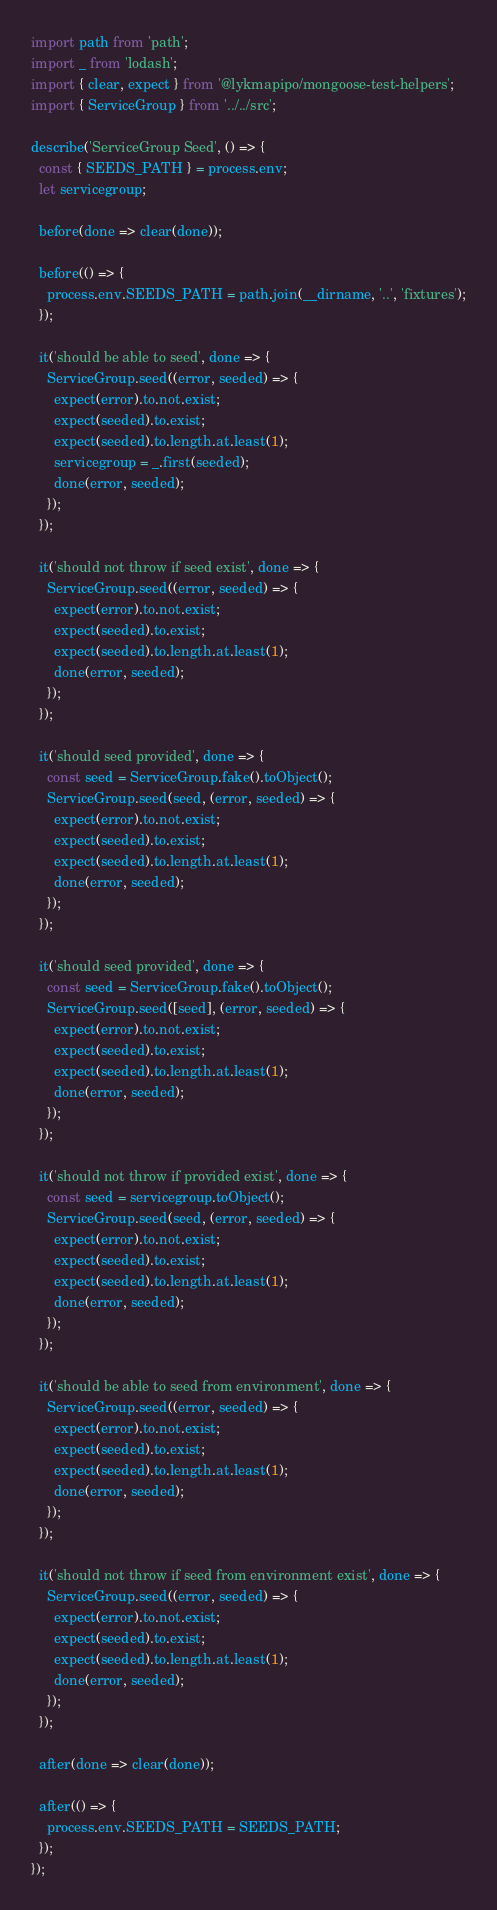Convert code to text. <code><loc_0><loc_0><loc_500><loc_500><_JavaScript_>import path from 'path';
import _ from 'lodash';
import { clear, expect } from '@lykmapipo/mongoose-test-helpers';
import { ServiceGroup } from '../../src';

describe('ServiceGroup Seed', () => {
  const { SEEDS_PATH } = process.env;
  let servicegroup;

  before(done => clear(done));

  before(() => {
    process.env.SEEDS_PATH = path.join(__dirname, '..', 'fixtures');
  });

  it('should be able to seed', done => {
    ServiceGroup.seed((error, seeded) => {
      expect(error).to.not.exist;
      expect(seeded).to.exist;
      expect(seeded).to.length.at.least(1);
      servicegroup = _.first(seeded);
      done(error, seeded);
    });
  });

  it('should not throw if seed exist', done => {
    ServiceGroup.seed((error, seeded) => {
      expect(error).to.not.exist;
      expect(seeded).to.exist;
      expect(seeded).to.length.at.least(1);
      done(error, seeded);
    });
  });

  it('should seed provided', done => {
    const seed = ServiceGroup.fake().toObject();
    ServiceGroup.seed(seed, (error, seeded) => {
      expect(error).to.not.exist;
      expect(seeded).to.exist;
      expect(seeded).to.length.at.least(1);
      done(error, seeded);
    });
  });

  it('should seed provided', done => {
    const seed = ServiceGroup.fake().toObject();
    ServiceGroup.seed([seed], (error, seeded) => {
      expect(error).to.not.exist;
      expect(seeded).to.exist;
      expect(seeded).to.length.at.least(1);
      done(error, seeded);
    });
  });

  it('should not throw if provided exist', done => {
    const seed = servicegroup.toObject();
    ServiceGroup.seed(seed, (error, seeded) => {
      expect(error).to.not.exist;
      expect(seeded).to.exist;
      expect(seeded).to.length.at.least(1);
      done(error, seeded);
    });
  });

  it('should be able to seed from environment', done => {
    ServiceGroup.seed((error, seeded) => {
      expect(error).to.not.exist;
      expect(seeded).to.exist;
      expect(seeded).to.length.at.least(1);
      done(error, seeded);
    });
  });

  it('should not throw if seed from environment exist', done => {
    ServiceGroup.seed((error, seeded) => {
      expect(error).to.not.exist;
      expect(seeded).to.exist;
      expect(seeded).to.length.at.least(1);
      done(error, seeded);
    });
  });

  after(done => clear(done));

  after(() => {
    process.env.SEEDS_PATH = SEEDS_PATH;
  });
});
</code> 